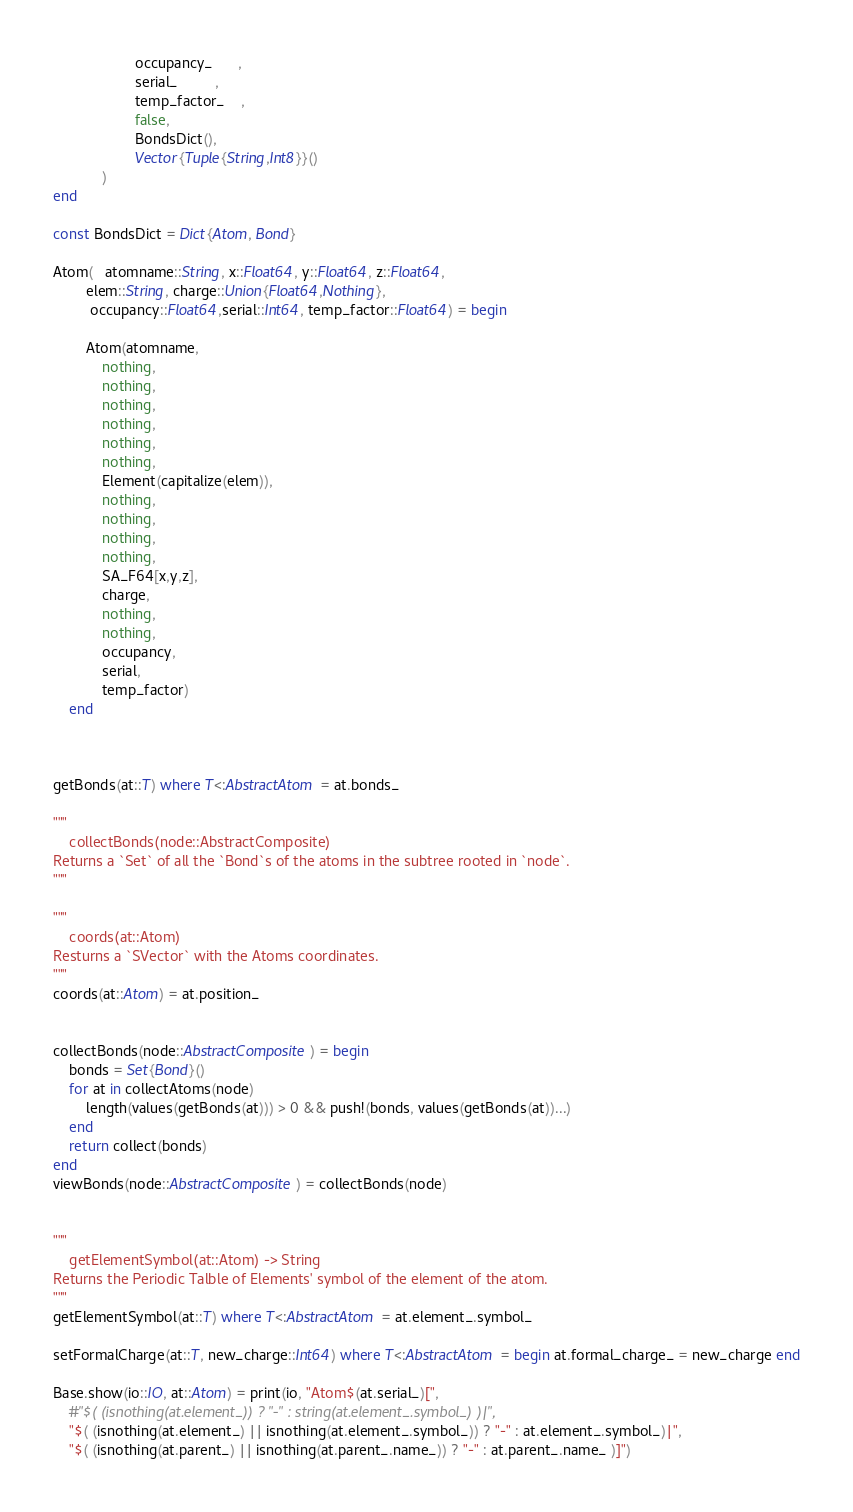<code> <loc_0><loc_0><loc_500><loc_500><_Julia_>                    occupancy_      ,
                    serial_         ,
                    temp_factor_    ,
                    false,
                    BondsDict(),
                    Vector{Tuple{String,Int8}}()
            )
end

const BondsDict = Dict{Atom, Bond}

Atom(   atomname::String, x::Float64, y::Float64, z::Float64,
        elem::String, charge::Union{Float64,Nothing},
         occupancy::Float64,serial::Int64, temp_factor::Float64) = begin

        Atom(atomname,
            nothing,
            nothing,
            nothing,
            nothing,
            nothing,
            nothing,
            Element(capitalize(elem)),
            nothing,
            nothing,
            nothing,
            nothing,
            SA_F64[x,y,z],
            charge,
            nothing,
            nothing,
            occupancy,
            serial,
            temp_factor)
    end



getBonds(at::T) where T<:AbstractAtom = at.bonds_

"""
    collectBonds(node::AbstractComposite)
Returns a `Set` of all the `Bond`s of the atoms in the subtree rooted in `node`.
"""

"""
    coords(at::Atom)
Resturns a `SVector` with the Atoms coordinates.
"""
coords(at::Atom) = at.position_


collectBonds(node::AbstractComposite) = begin
    bonds = Set{Bond}()
    for at in collectAtoms(node)
        length(values(getBonds(at))) > 0 && push!(bonds, values(getBonds(at))...)
    end
    return collect(bonds)
end
viewBonds(node::AbstractComposite) = collectBonds(node)


"""
    getElementSymbol(at::Atom) -> String
Returns the Periodic Talble of Elements' symbol of the element of the atom.
"""
getElementSymbol(at::T) where T<:AbstractAtom = at.element_.symbol_

setFormalCharge(at::T, new_charge::Int64) where T<:AbstractAtom = begin at.formal_charge_ = new_charge end

Base.show(io::IO, at::Atom) = print(io, "Atom$(at.serial_)[",
    #"$( (isnothing(at.element_)) ? "-" : string(at.element_.symbol_) )|",
    "$( (isnothing(at.element_) || isnothing(at.element_.symbol_)) ? "-" : at.element_.symbol_)|",
    "$( (isnothing(at.parent_) || isnothing(at.parent_.name_)) ? "-" : at.parent_.name_ )]")
</code> 